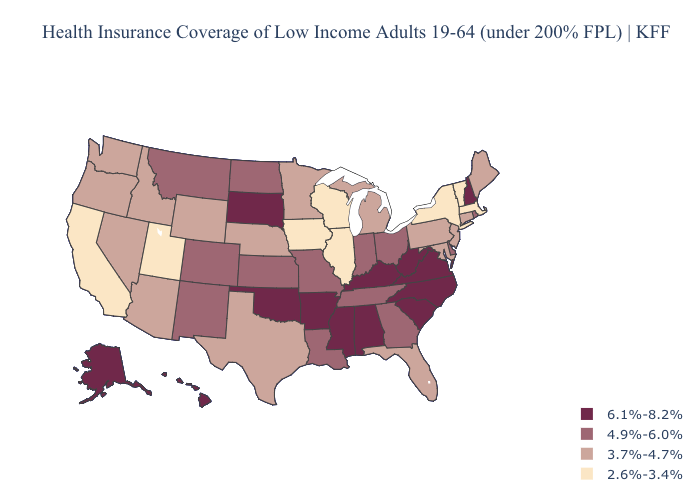Does New Hampshire have the same value as South Dakota?
Answer briefly. Yes. Among the states that border Vermont , which have the highest value?
Concise answer only. New Hampshire. Name the states that have a value in the range 4.9%-6.0%?
Be succinct. Colorado, Delaware, Georgia, Indiana, Kansas, Louisiana, Missouri, Montana, New Mexico, North Dakota, Ohio, Rhode Island, Tennessee. What is the lowest value in the West?
Keep it brief. 2.6%-3.4%. Name the states that have a value in the range 6.1%-8.2%?
Concise answer only. Alabama, Alaska, Arkansas, Hawaii, Kentucky, Mississippi, New Hampshire, North Carolina, Oklahoma, South Carolina, South Dakota, Virginia, West Virginia. Name the states that have a value in the range 6.1%-8.2%?
Write a very short answer. Alabama, Alaska, Arkansas, Hawaii, Kentucky, Mississippi, New Hampshire, North Carolina, Oklahoma, South Carolina, South Dakota, Virginia, West Virginia. What is the value of New Jersey?
Give a very brief answer. 3.7%-4.7%. Does Kansas have the same value as Rhode Island?
Give a very brief answer. Yes. Which states have the lowest value in the MidWest?
Be succinct. Illinois, Iowa, Wisconsin. Name the states that have a value in the range 4.9%-6.0%?
Be succinct. Colorado, Delaware, Georgia, Indiana, Kansas, Louisiana, Missouri, Montana, New Mexico, North Dakota, Ohio, Rhode Island, Tennessee. Name the states that have a value in the range 4.9%-6.0%?
Quick response, please. Colorado, Delaware, Georgia, Indiana, Kansas, Louisiana, Missouri, Montana, New Mexico, North Dakota, Ohio, Rhode Island, Tennessee. Which states have the highest value in the USA?
Quick response, please. Alabama, Alaska, Arkansas, Hawaii, Kentucky, Mississippi, New Hampshire, North Carolina, Oklahoma, South Carolina, South Dakota, Virginia, West Virginia. Name the states that have a value in the range 2.6%-3.4%?
Give a very brief answer. California, Illinois, Iowa, Massachusetts, New York, Utah, Vermont, Wisconsin. Name the states that have a value in the range 3.7%-4.7%?
Give a very brief answer. Arizona, Connecticut, Florida, Idaho, Maine, Maryland, Michigan, Minnesota, Nebraska, Nevada, New Jersey, Oregon, Pennsylvania, Texas, Washington, Wyoming. Among the states that border Nevada , does Arizona have the highest value?
Quick response, please. Yes. 